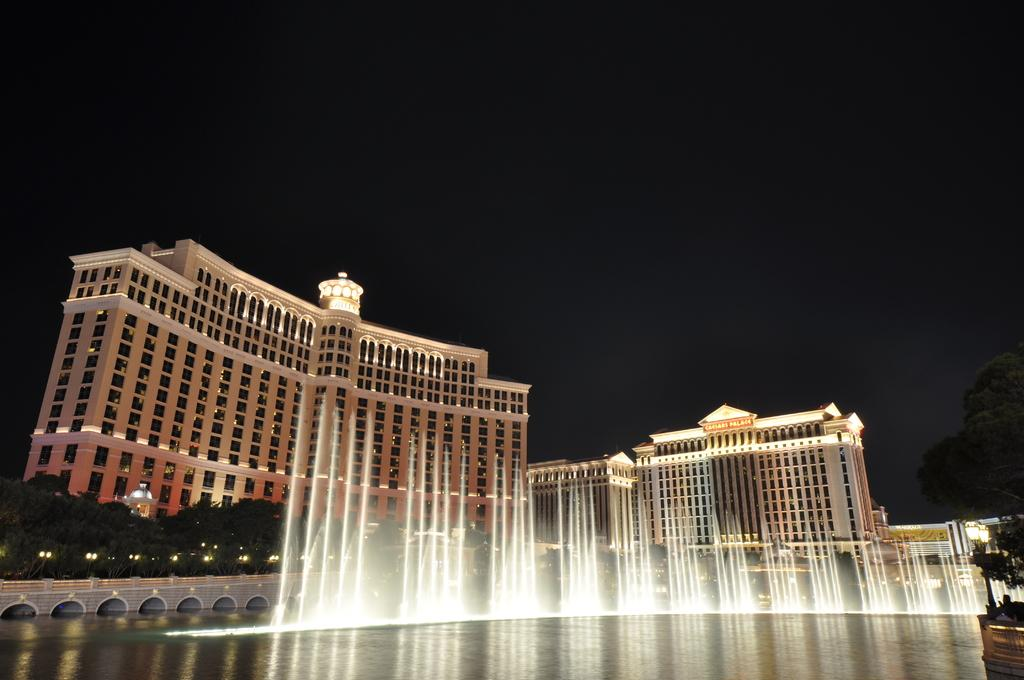What is visible in the image? Water is visible in the image. What can be seen in the background of the image? There are buildings, trees, lights, and the sky visible in the background of the image. Where is the turkey being held in the image? There is no turkey present in the image. What type of prison can be seen in the image? There is no prison present in the image. 